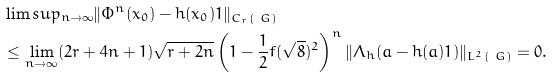Convert formula to latex. <formula><loc_0><loc_0><loc_500><loc_500>& \lim s u p _ { n \to \infty } \| \Phi ^ { n } ( x _ { 0 } ) - h ( x _ { 0 } ) 1 \| _ { C _ { r } ( \ G ) } \\ & \leq \lim _ { n \to \infty } ( 2 r + 4 n + 1 ) \sqrt { r + 2 n } \left ( 1 - \frac { 1 } { 2 } f ( \sqrt { 8 } ) ^ { 2 } \right ) ^ { n } \| \Lambda _ { h } ( a - h ( a ) 1 ) \| _ { L ^ { 2 } ( \ G ) } = 0 .</formula> 